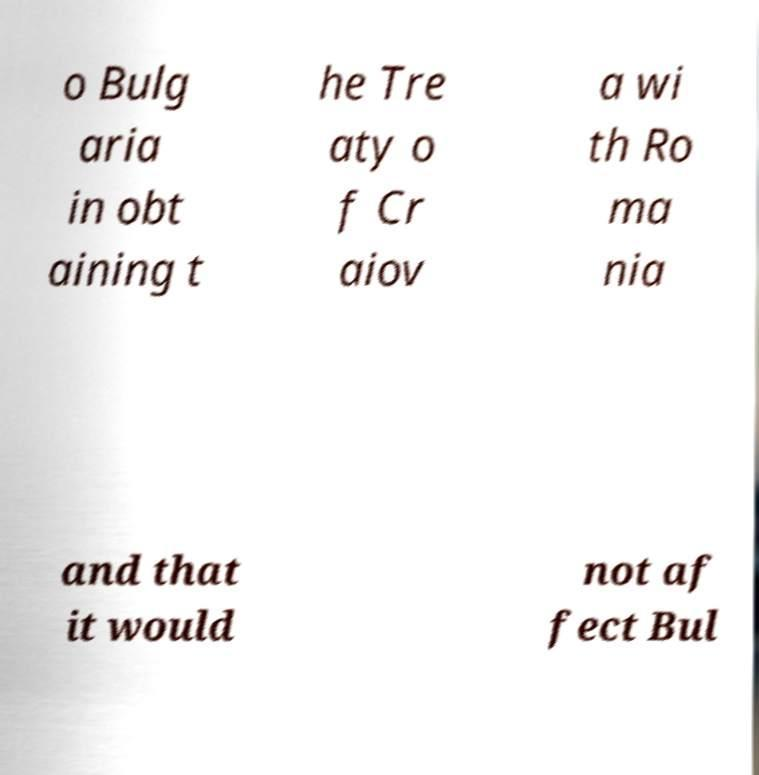Can you read and provide the text displayed in the image?This photo seems to have some interesting text. Can you extract and type it out for me? o Bulg aria in obt aining t he Tre aty o f Cr aiov a wi th Ro ma nia and that it would not af fect Bul 